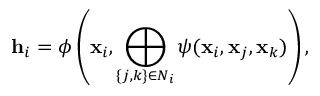<formula> <loc_0><loc_0><loc_500><loc_500>h _ { i } = \phi \left ( x _ { i } , \bigoplus _ { \{ j , k \} \in N _ { i } } \psi ( x _ { i } , x _ { j } , x _ { k } ) \right ) ,</formula> 